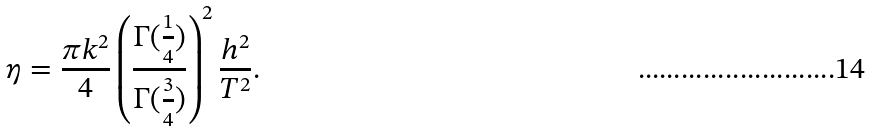<formula> <loc_0><loc_0><loc_500><loc_500>\eta = \frac { \pi k ^ { 2 } } { 4 } \left ( \frac { \Gamma ( \frac { 1 } { 4 } ) } { \Gamma ( \frac { 3 } { 4 } ) } \right ) ^ { 2 } \frac { h ^ { 2 } } { T ^ { 2 } } .</formula> 